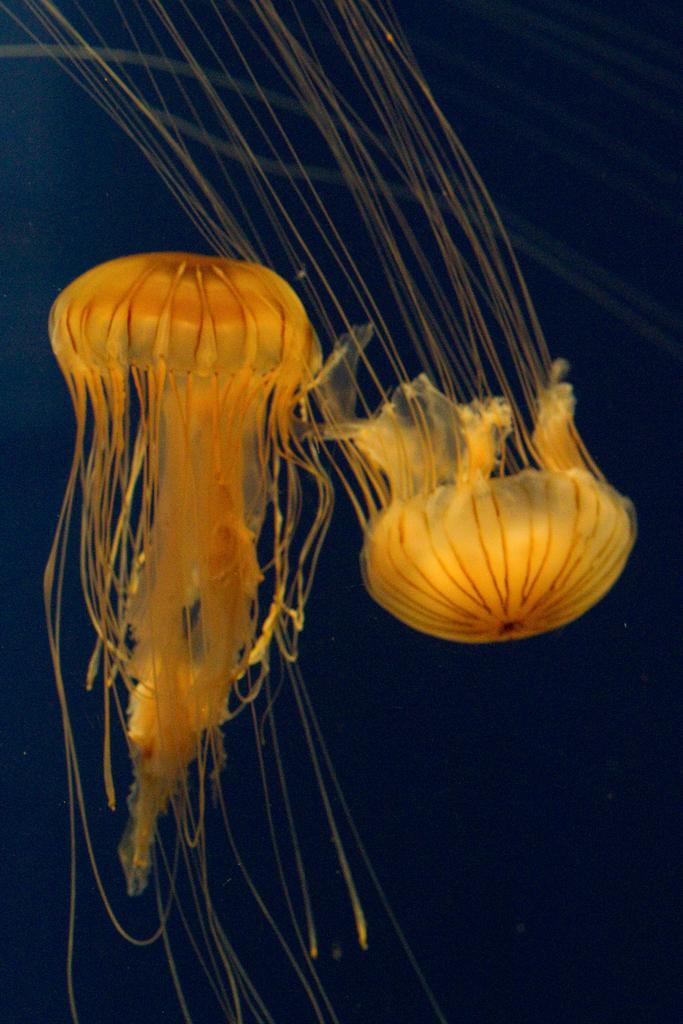How would you summarize this image in a sentence or two? In this image in the middle two yellow color jellyfish visible, background is dark 